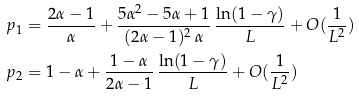Convert formula to latex. <formula><loc_0><loc_0><loc_500><loc_500>p _ { 1 } & = \frac { 2 \alpha - 1 } { \alpha } + \frac { 5 \alpha ^ { 2 } - 5 \alpha + 1 } { ( 2 \alpha - 1 ) ^ { 2 } \, \alpha } \, \frac { \ln ( 1 - \gamma ) } { L } + O ( \frac { 1 } { L ^ { 2 } } ) \\ p _ { 2 } & = 1 - \alpha + \frac { 1 - \alpha } { 2 \alpha - 1 } \, \frac { \ln ( 1 - \gamma ) } { L } + O ( \frac { 1 } { L ^ { 2 } } )</formula> 